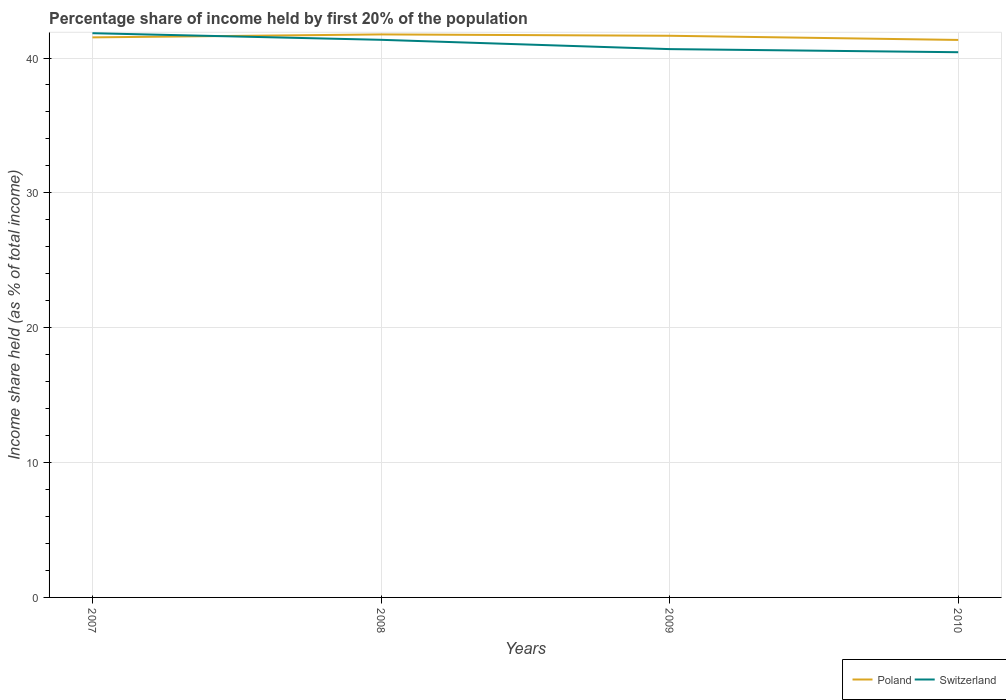How many different coloured lines are there?
Make the answer very short. 2. Does the line corresponding to Switzerland intersect with the line corresponding to Poland?
Ensure brevity in your answer.  Yes. Is the number of lines equal to the number of legend labels?
Offer a terse response. Yes. Across all years, what is the maximum share of income held by first 20% of the population in Poland?
Keep it short and to the point. 41.34. In which year was the share of income held by first 20% of the population in Switzerland maximum?
Keep it short and to the point. 2010. What is the total share of income held by first 20% of the population in Poland in the graph?
Your answer should be compact. -0.22. What is the difference between the highest and the second highest share of income held by first 20% of the population in Switzerland?
Your answer should be compact. 1.41. What is the difference between the highest and the lowest share of income held by first 20% of the population in Poland?
Provide a succinct answer. 2. Is the share of income held by first 20% of the population in Switzerland strictly greater than the share of income held by first 20% of the population in Poland over the years?
Ensure brevity in your answer.  No. What is the title of the graph?
Offer a terse response. Percentage share of income held by first 20% of the population. What is the label or title of the X-axis?
Your answer should be compact. Years. What is the label or title of the Y-axis?
Provide a succinct answer. Income share held (as % of total income). What is the Income share held (as % of total income) of Poland in 2007?
Your answer should be compact. 41.53. What is the Income share held (as % of total income) of Switzerland in 2007?
Your answer should be compact. 41.84. What is the Income share held (as % of total income) of Poland in 2008?
Offer a very short reply. 41.75. What is the Income share held (as % of total income) in Switzerland in 2008?
Give a very brief answer. 41.35. What is the Income share held (as % of total income) of Poland in 2009?
Keep it short and to the point. 41.65. What is the Income share held (as % of total income) in Switzerland in 2009?
Your answer should be compact. 40.66. What is the Income share held (as % of total income) of Poland in 2010?
Offer a terse response. 41.34. What is the Income share held (as % of total income) of Switzerland in 2010?
Your answer should be very brief. 40.43. Across all years, what is the maximum Income share held (as % of total income) of Poland?
Make the answer very short. 41.75. Across all years, what is the maximum Income share held (as % of total income) of Switzerland?
Make the answer very short. 41.84. Across all years, what is the minimum Income share held (as % of total income) in Poland?
Offer a terse response. 41.34. Across all years, what is the minimum Income share held (as % of total income) of Switzerland?
Your response must be concise. 40.43. What is the total Income share held (as % of total income) of Poland in the graph?
Ensure brevity in your answer.  166.27. What is the total Income share held (as % of total income) in Switzerland in the graph?
Provide a succinct answer. 164.28. What is the difference between the Income share held (as % of total income) in Poland in 2007 and that in 2008?
Provide a short and direct response. -0.22. What is the difference between the Income share held (as % of total income) in Switzerland in 2007 and that in 2008?
Give a very brief answer. 0.49. What is the difference between the Income share held (as % of total income) of Poland in 2007 and that in 2009?
Make the answer very short. -0.12. What is the difference between the Income share held (as % of total income) of Switzerland in 2007 and that in 2009?
Your answer should be very brief. 1.18. What is the difference between the Income share held (as % of total income) of Poland in 2007 and that in 2010?
Your response must be concise. 0.19. What is the difference between the Income share held (as % of total income) in Switzerland in 2007 and that in 2010?
Ensure brevity in your answer.  1.41. What is the difference between the Income share held (as % of total income) of Poland in 2008 and that in 2009?
Your response must be concise. 0.1. What is the difference between the Income share held (as % of total income) in Switzerland in 2008 and that in 2009?
Keep it short and to the point. 0.69. What is the difference between the Income share held (as % of total income) in Poland in 2008 and that in 2010?
Keep it short and to the point. 0.41. What is the difference between the Income share held (as % of total income) of Poland in 2009 and that in 2010?
Provide a short and direct response. 0.31. What is the difference between the Income share held (as % of total income) in Switzerland in 2009 and that in 2010?
Make the answer very short. 0.23. What is the difference between the Income share held (as % of total income) in Poland in 2007 and the Income share held (as % of total income) in Switzerland in 2008?
Ensure brevity in your answer.  0.18. What is the difference between the Income share held (as % of total income) of Poland in 2007 and the Income share held (as % of total income) of Switzerland in 2009?
Offer a terse response. 0.87. What is the difference between the Income share held (as % of total income) of Poland in 2008 and the Income share held (as % of total income) of Switzerland in 2009?
Provide a succinct answer. 1.09. What is the difference between the Income share held (as % of total income) of Poland in 2008 and the Income share held (as % of total income) of Switzerland in 2010?
Give a very brief answer. 1.32. What is the difference between the Income share held (as % of total income) in Poland in 2009 and the Income share held (as % of total income) in Switzerland in 2010?
Provide a succinct answer. 1.22. What is the average Income share held (as % of total income) in Poland per year?
Provide a succinct answer. 41.57. What is the average Income share held (as % of total income) in Switzerland per year?
Provide a succinct answer. 41.07. In the year 2007, what is the difference between the Income share held (as % of total income) of Poland and Income share held (as % of total income) of Switzerland?
Offer a terse response. -0.31. In the year 2008, what is the difference between the Income share held (as % of total income) of Poland and Income share held (as % of total income) of Switzerland?
Offer a very short reply. 0.4. In the year 2009, what is the difference between the Income share held (as % of total income) of Poland and Income share held (as % of total income) of Switzerland?
Provide a short and direct response. 0.99. In the year 2010, what is the difference between the Income share held (as % of total income) of Poland and Income share held (as % of total income) of Switzerland?
Provide a succinct answer. 0.91. What is the ratio of the Income share held (as % of total income) of Poland in 2007 to that in 2008?
Give a very brief answer. 0.99. What is the ratio of the Income share held (as % of total income) in Switzerland in 2007 to that in 2008?
Give a very brief answer. 1.01. What is the ratio of the Income share held (as % of total income) in Switzerland in 2007 to that in 2009?
Provide a succinct answer. 1.03. What is the ratio of the Income share held (as % of total income) of Poland in 2007 to that in 2010?
Ensure brevity in your answer.  1. What is the ratio of the Income share held (as % of total income) in Switzerland in 2007 to that in 2010?
Keep it short and to the point. 1.03. What is the ratio of the Income share held (as % of total income) of Poland in 2008 to that in 2009?
Keep it short and to the point. 1. What is the ratio of the Income share held (as % of total income) in Poland in 2008 to that in 2010?
Provide a short and direct response. 1.01. What is the ratio of the Income share held (as % of total income) in Switzerland in 2008 to that in 2010?
Your answer should be compact. 1.02. What is the ratio of the Income share held (as % of total income) of Poland in 2009 to that in 2010?
Your answer should be compact. 1.01. What is the difference between the highest and the second highest Income share held (as % of total income) in Switzerland?
Make the answer very short. 0.49. What is the difference between the highest and the lowest Income share held (as % of total income) in Poland?
Give a very brief answer. 0.41. What is the difference between the highest and the lowest Income share held (as % of total income) in Switzerland?
Your answer should be very brief. 1.41. 